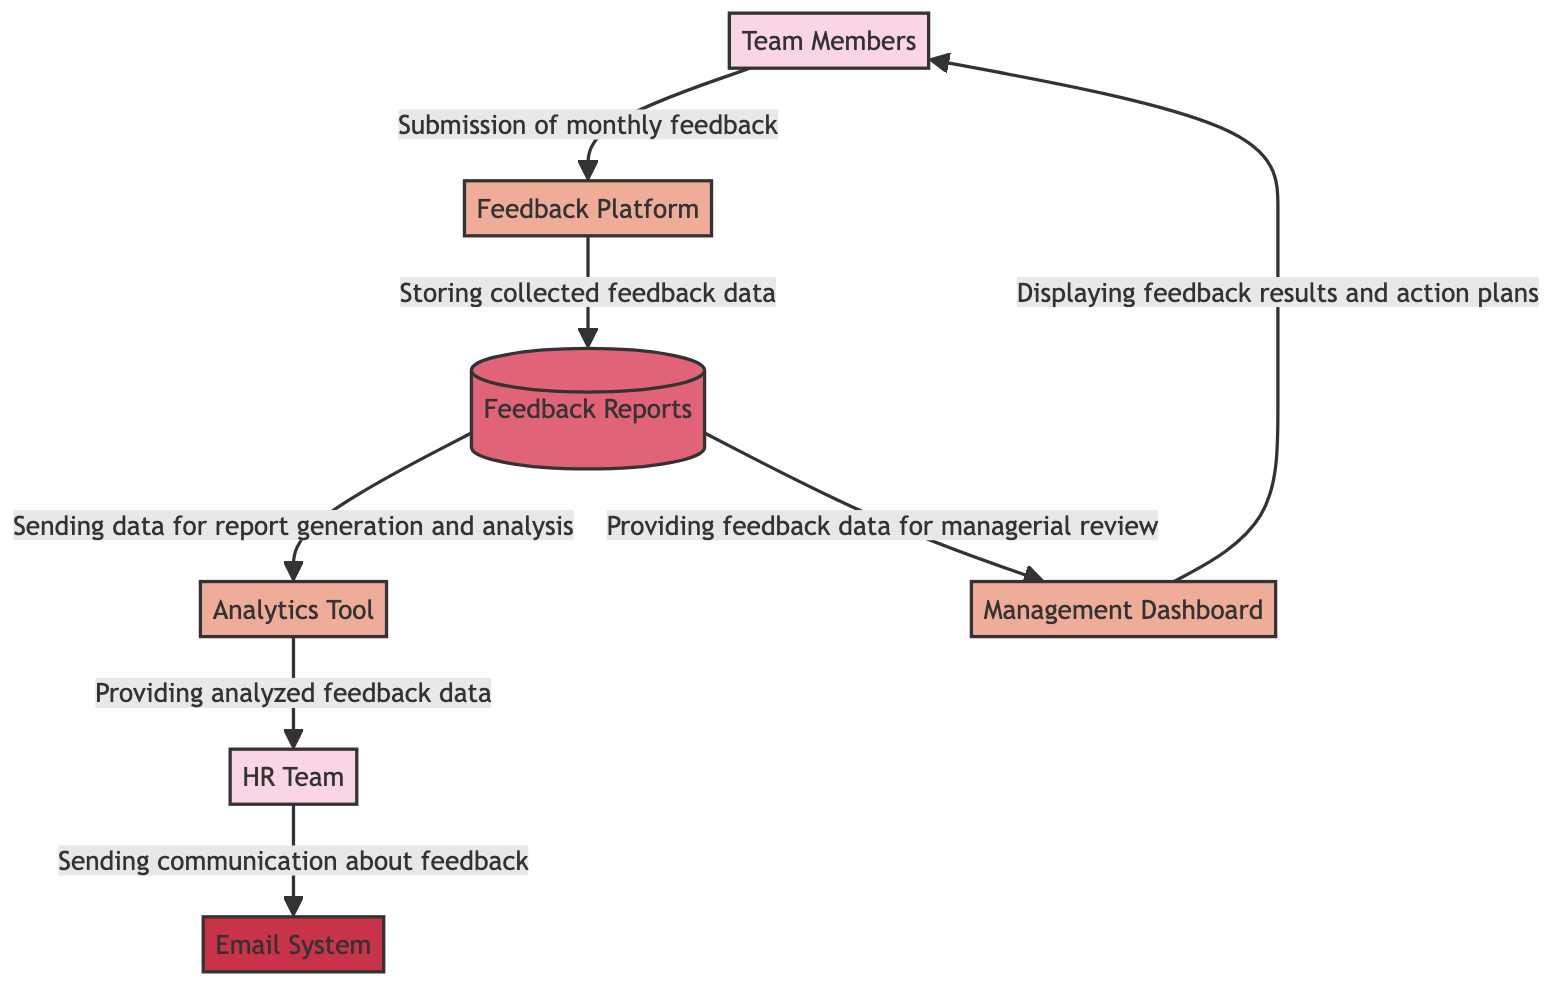What are the two external entities in the diagram? The diagram includes two external entities: "Team Members" and "HR Team". These are represented in separate nodes of the diagram.
Answer: Team Members, HR Team How many processes are depicted in the diagram? Upon counting the nodes designated as processes, there are four processes in total: "Feedback Platform", "Management Dashboard", "Analytics Tool", and one more named process.
Answer: Four Which entity submits monthly feedback? The diagram specifies that the "Team Members" node is the entity responsible for submitting monthly feedback to the feedback platform.
Answer: Team Members What type of communication channel is used for notifying team members? The diagram identifies the "Email System" as the communication channel utilized for notifications, which is categorized separately in the diagram.
Answer: Email System What does the "Analytics Tool" provide to the "HR Team"? According to the flow in the diagram, the "Analytics Tool" provides "analyzed feedback data" to the "HR Team", showing the direction of data transfer between these nodes.
Answer: Analyzed feedback data What flow occurs from "Feedback Reports" to "Management Dashboard"? The diagram illustrates that there is a flow from "Feedback Reports" to "Management Dashboard" with the description of "providing feedback data for managerial review". This indicates the purpose of this specific flow between those two nodes.
Answer: Providing feedback data for managerial review Which process is responsible for storing collected feedback data? In the diagram, the "Feedback Platform" process is clearly identified as the one that stores the collected feedback data in the feedback reports, indicating its function in the overall data flow.
Answer: Feedback Platform What is the main action performed by the "Feedback Platform"? The "Feedback Platform" is primarily engaged in the "submission of monthly feedback", which is its main function as depicted in the flow from "Team Members".
Answer: Submission of monthly feedback 